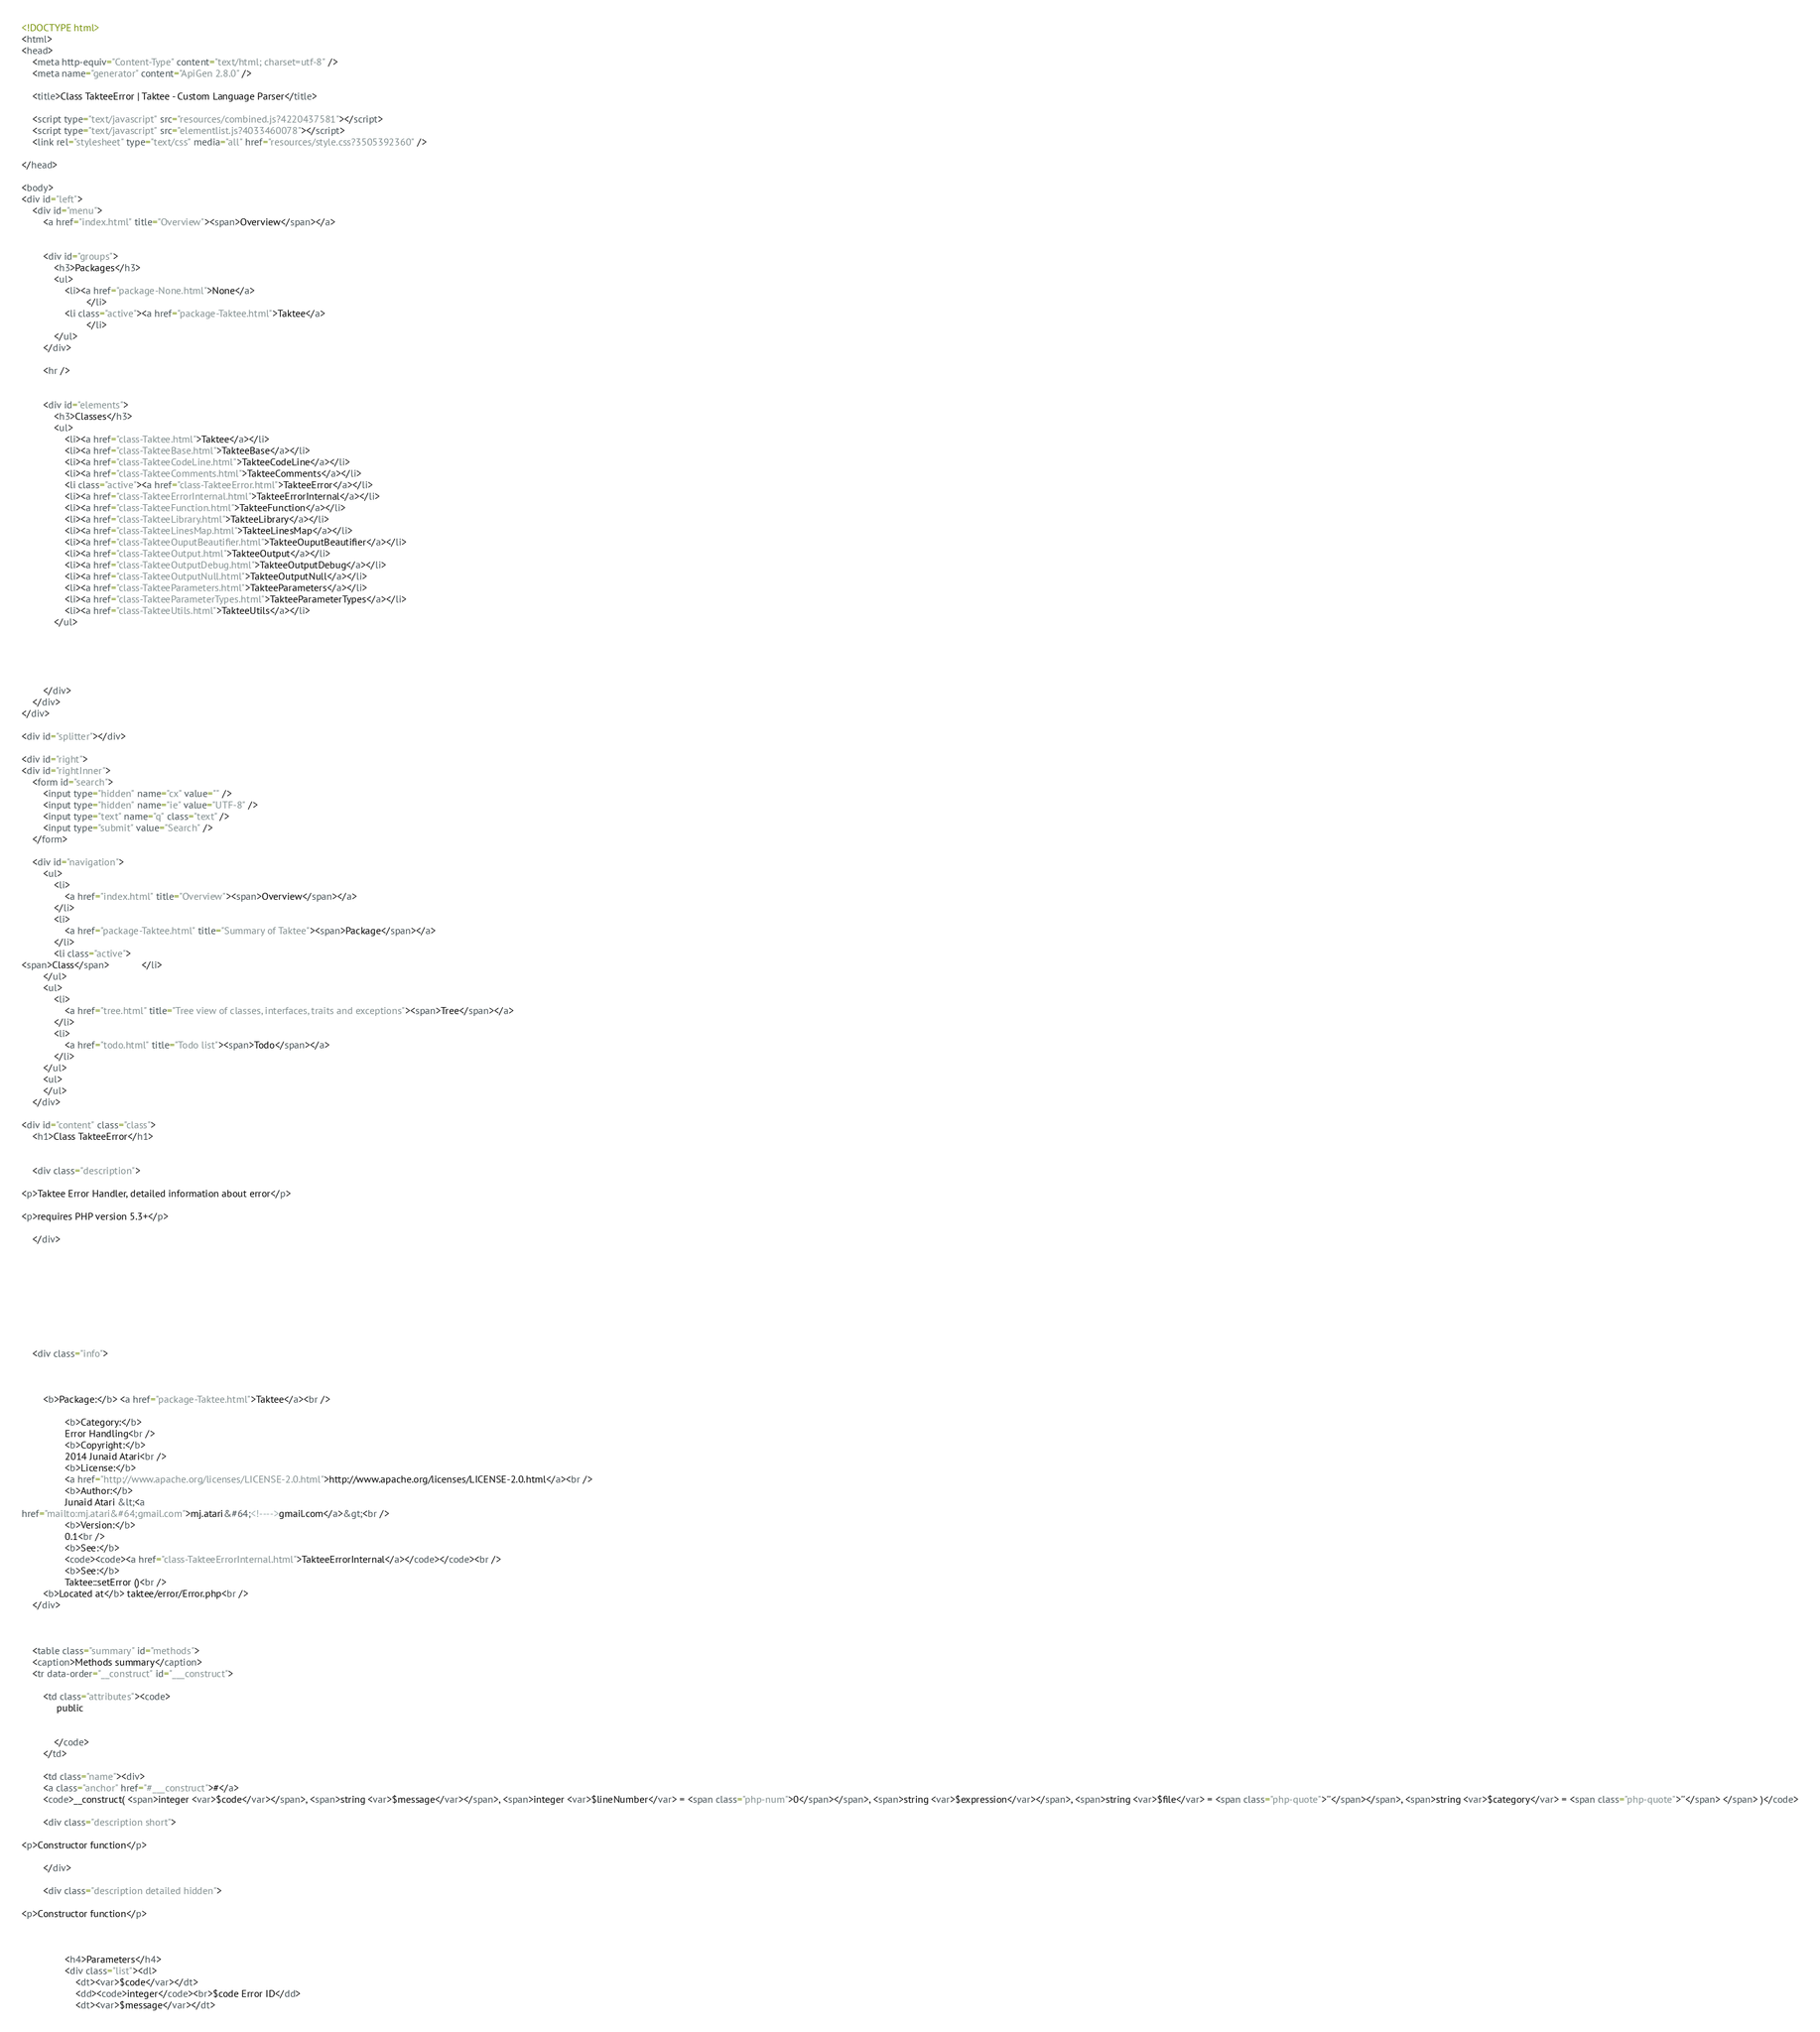<code> <loc_0><loc_0><loc_500><loc_500><_HTML_><!DOCTYPE html>
<html>
<head>
	<meta http-equiv="Content-Type" content="text/html; charset=utf-8" />
	<meta name="generator" content="ApiGen 2.8.0" />

	<title>Class TakteeError | Taktee - Custom Language Parser</title>

	<script type="text/javascript" src="resources/combined.js?4220437581"></script>
	<script type="text/javascript" src="elementlist.js?4033460078"></script>
	<link rel="stylesheet" type="text/css" media="all" href="resources/style.css?3505392360" />

</head>

<body>
<div id="left">
	<div id="menu">
		<a href="index.html" title="Overview"><span>Overview</span></a>


		<div id="groups">
			<h3>Packages</h3>
			<ul>
				<li><a href="package-None.html">None</a>
						</li>
				<li class="active"><a href="package-Taktee.html">Taktee</a>
						</li>
			</ul>
		</div>

		<hr />


		<div id="elements">
			<h3>Classes</h3>
			<ul>
				<li><a href="class-Taktee.html">Taktee</a></li>
				<li><a href="class-TakteeBase.html">TakteeBase</a></li>
				<li><a href="class-TakteeCodeLine.html">TakteeCodeLine</a></li>
				<li><a href="class-TakteeComments.html">TakteeComments</a></li>
				<li class="active"><a href="class-TakteeError.html">TakteeError</a></li>
				<li><a href="class-TakteeErrorInternal.html">TakteeErrorInternal</a></li>
				<li><a href="class-TakteeFunction.html">TakteeFunction</a></li>
				<li><a href="class-TakteeLibrary.html">TakteeLibrary</a></li>
				<li><a href="class-TakteeLinesMap.html">TakteeLinesMap</a></li>
				<li><a href="class-TakteeOuputBeautifier.html">TakteeOuputBeautifier</a></li>
				<li><a href="class-TakteeOutput.html">TakteeOutput</a></li>
				<li><a href="class-TakteeOutputDebug.html">TakteeOutputDebug</a></li>
				<li><a href="class-TakteeOutputNull.html">TakteeOutputNull</a></li>
				<li><a href="class-TakteeParameters.html">TakteeParameters</a></li>
				<li><a href="class-TakteeParameterTypes.html">TakteeParameterTypes</a></li>
				<li><a href="class-TakteeUtils.html">TakteeUtils</a></li>
			</ul>





		</div>
	</div>
</div>

<div id="splitter"></div>

<div id="right">
<div id="rightInner">
	<form id="search">
		<input type="hidden" name="cx" value="" />
		<input type="hidden" name="ie" value="UTF-8" />
		<input type="text" name="q" class="text" />
		<input type="submit" value="Search" />
	</form>

	<div id="navigation">
		<ul>
			<li>
				<a href="index.html" title="Overview"><span>Overview</span></a>
			</li>
			<li>
				<a href="package-Taktee.html" title="Summary of Taktee"><span>Package</span></a>
			</li>
			<li class="active">
<span>Class</span>			</li>
		</ul>
		<ul>
			<li>
				<a href="tree.html" title="Tree view of classes, interfaces, traits and exceptions"><span>Tree</span></a>
			</li>
			<li>
				<a href="todo.html" title="Todo list"><span>Todo</span></a>
			</li>
		</ul>
		<ul>
		</ul>
	</div>

<div id="content" class="class">
	<h1>Class TakteeError</h1>


	<div class="description">
	
<p>Taktee Error Handler, detailed information about error</p>

<p>requires PHP version 5.3+</p>

	</div>









	<div class="info">
		
		
		
		<b>Package:</b> <a href="package-Taktee.html">Taktee</a><br />

				<b>Category:</b>
				Error Handling<br />
				<b>Copyright:</b>
				2014 Junaid Atari<br />
				<b>License:</b>
				<a href="http://www.apache.org/licenses/LICENSE-2.0.html">http://www.apache.org/licenses/LICENSE-2.0.html</a><br />
				<b>Author:</b>
				Junaid Atari &lt;<a
href="mailto:mj.atari&#64;gmail.com">mj.atari&#64;<!---->gmail.com</a>&gt;<br />
				<b>Version:</b>
				0.1<br />
				<b>See:</b>
				<code><code><a href="class-TakteeErrorInternal.html">TakteeErrorInternal</a></code></code><br />
				<b>See:</b>
				Taktee::setError ()<br />
		<b>Located at</b> taktee/error/Error.php<br />
	</div>



	<table class="summary" id="methods">
	<caption>Methods summary</caption>
	<tr data-order="__construct" id="___construct">

		<td class="attributes"><code>
			 public 
			
			
			</code>
		</td>

		<td class="name"><div>
		<a class="anchor" href="#___construct">#</a>
		<code>__construct( <span>integer <var>$code</var></span>, <span>string <var>$message</var></span>, <span>integer <var>$lineNumber</var> = <span class="php-num">0</span></span>, <span>string <var>$expression</var></span>, <span>string <var>$file</var> = <span class="php-quote">''</span></span>, <span>string <var>$category</var> = <span class="php-quote">''</span> </span> )</code>

		<div class="description short">
			
<p>Constructor function</p>

		</div>

		<div class="description detailed hidden">
			
<p>Constructor function</p>



				<h4>Parameters</h4>
				<div class="list"><dl>
					<dt><var>$code</var></dt>
					<dd><code>integer</code><br>$code Error ID</dd>
					<dt><var>$message</var></dt></code> 